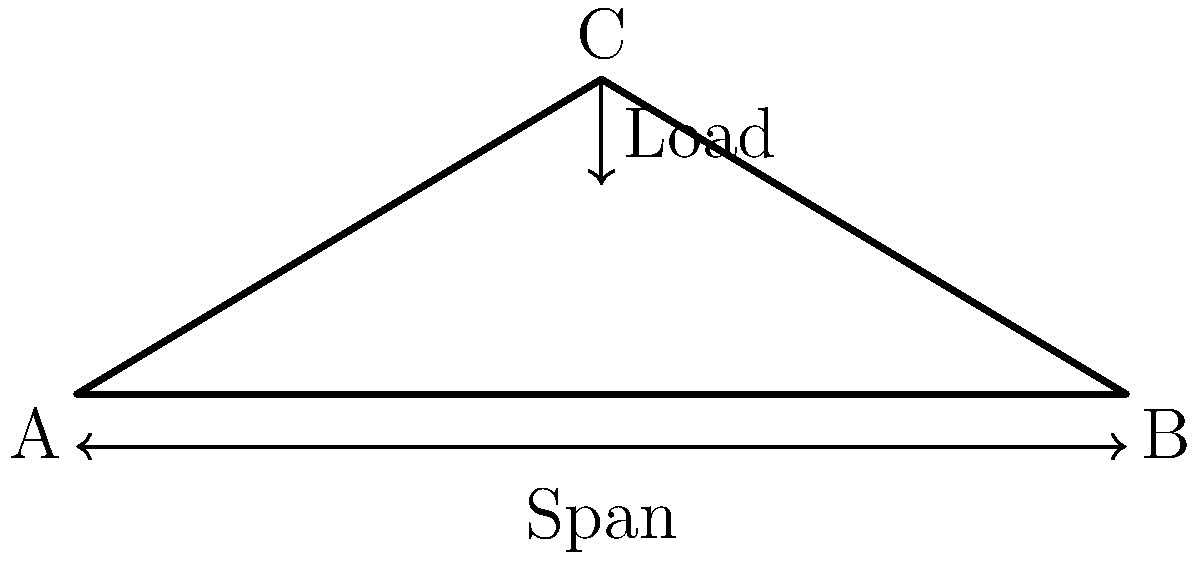For the given roof truss design, which has a span of 10 meters and a central point load, determine the most efficient angle θ between the horizontal and the roof truss member to minimize the axial forces in the truss members. Assume the truss is symmetrical. To determine the most efficient angle for the roof truss, we need to minimize the axial forces in the truss members. The process involves the following steps:

1. Express the axial forces in terms of the angle θ:
   Let P be the applied load, L be the span, and H be the height of the truss.
   
   Axial force in the roof member: $F_r = \frac{P}{2\sin\theta}$
   Axial force in the bottom chord: $F_b = \frac{PL}{4H} = \frac{P}{4\tan\theta}$

2. The total force in the system is proportional to:
   $F_{total} \propto F_r + F_b = \frac{P}{2\sin\theta} + \frac{P}{4\tan\theta}$

3. To minimize $F_{total}$, we differentiate it with respect to θ and set it to zero:
   $\frac{d}{d\theta}(\frac{1}{2\sin\theta} + \frac{1}{4\tan\theta}) = 0$

4. Solving this equation leads to:
   $\cos\theta = \frac{1}{\sqrt{3}}$

5. Therefore, the optimal angle is:
   $\theta = \arccos(\frac{1}{\sqrt{3}}) \approx 54.7°$

This angle of approximately 54.7° (or about 55°) between the horizontal and the roof truss member will minimize the axial forces in the truss members, making it the most efficient design for the given span and load.
Answer: 54.7° 